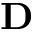Convert formula to latex. <formula><loc_0><loc_0><loc_500><loc_500>D</formula> 